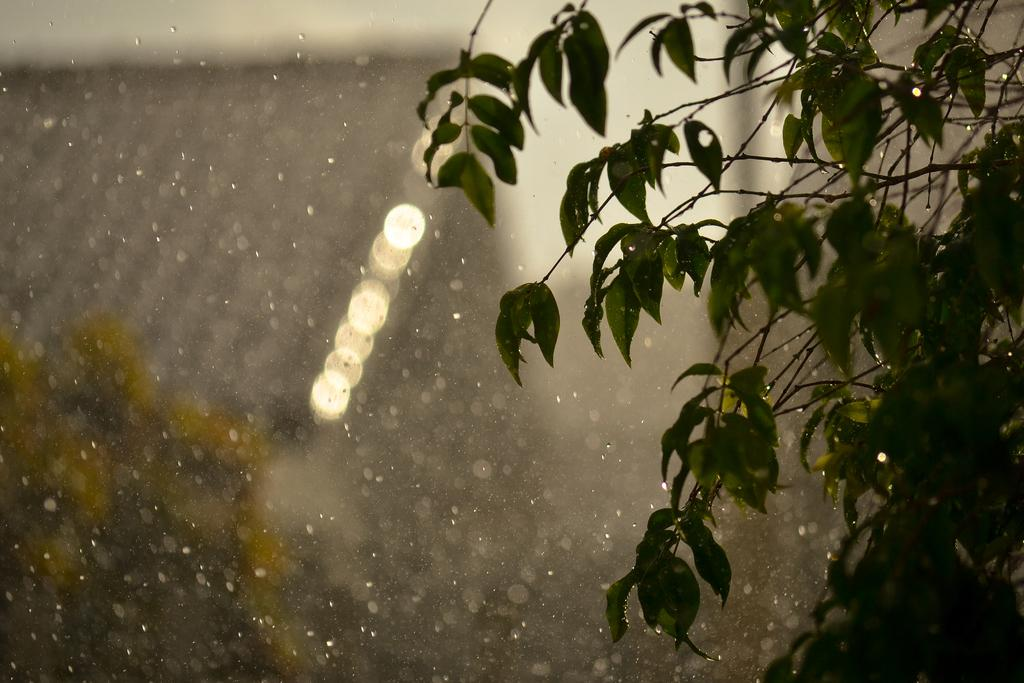What type of living organisms can be seen in the image? Plants are visible in the image. Can you describe the background of the image? The background of the image is blurred. What can be seen in the background of the image besides the blurred area? There are lights visible in the background of the image. How does the comparison between the plants and the net affect the pigs in the image? There are no pigs, comparison, or net present in the image, so this question cannot be answered. 